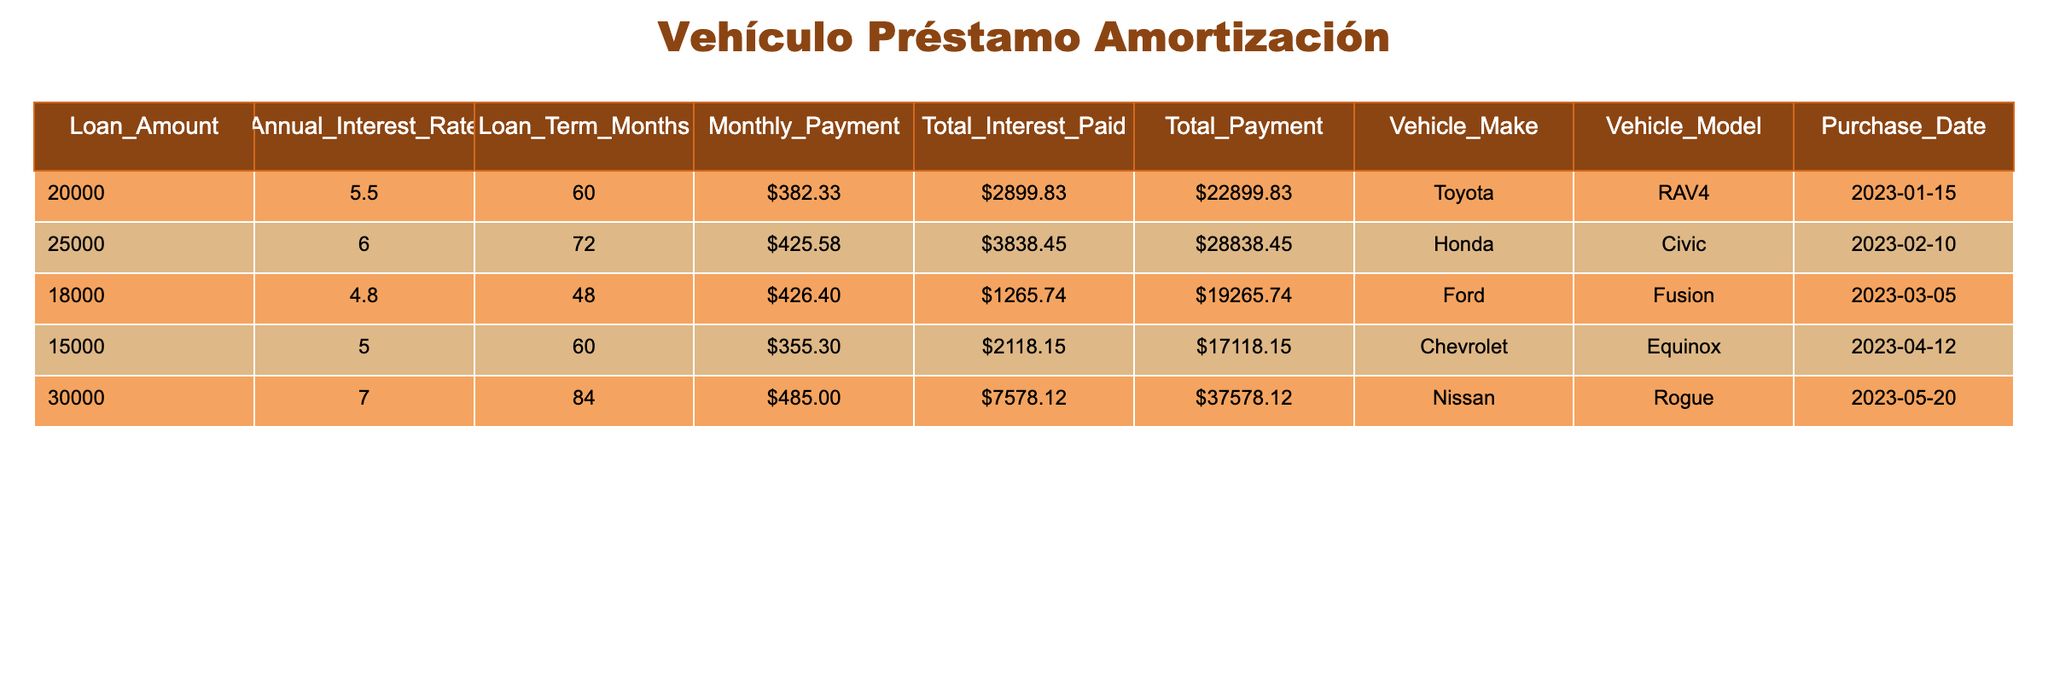What is the monthly payment for the Toyota RAV4? The table indicates that the monthly payment for the Toyota RAV4 is specified in the "Monthly_Payment" column, which shows the amount of 382.33.
Answer: 382.33 What is the total interest paid for the Honda Civic? Referring to the "Total_Interest_Paid" column for the Honda Civic, the value 3838.45 is found.
Answer: 3838.45 Which vehicle has the highest loan amount? By examining the "Loan_Amount" column, the Nissan Rogue has the highest amount listed at 30000.
Answer: Nissan Rogue What is the average monthly payment across all vehicles? First, we add the monthly payments: (382.33 + 425.58 + 426.40 + 355.30 + 485.00) = 2074.61. Then, divide by the number of vehicles, 5: 2074.61 / 5 = 414.92.
Answer: 414.92 Is the total payment for the Ford Fusion less than 20000? The total payment for the Ford Fusion is found in the "Total_Payment" column and is specified as 19265.74, which is less than 20000.
Answer: Yes What is the difference in total payment between the Nissan Rogue and the Chevrolet Equinox? The total payment for the Nissan Rogue is 37578.12 and for the Chevrolet Equinox is 17118.15. The difference is calculated by subtracting: 37578.12 - 17118.15 = 20459.97.
Answer: 20459.97 Are any of the vehicles purchased in 2023? All vehicles in the table, listed with their purchase dates, were acquired in 2023.
Answer: Yes Which vehicle has the lowest annual interest rate? By reviewing the "Annual_Interest_Rate" column, the Ford Fusion has the lowest rate of 4.8%.
Answer: Ford Fusion What is the highest total interest paid among all vehicles? The "Total_Interest_Paid" values are compared, revealing that the Nissan Rogue has the highest total interest paid at 7578.12.
Answer: 7578.12 